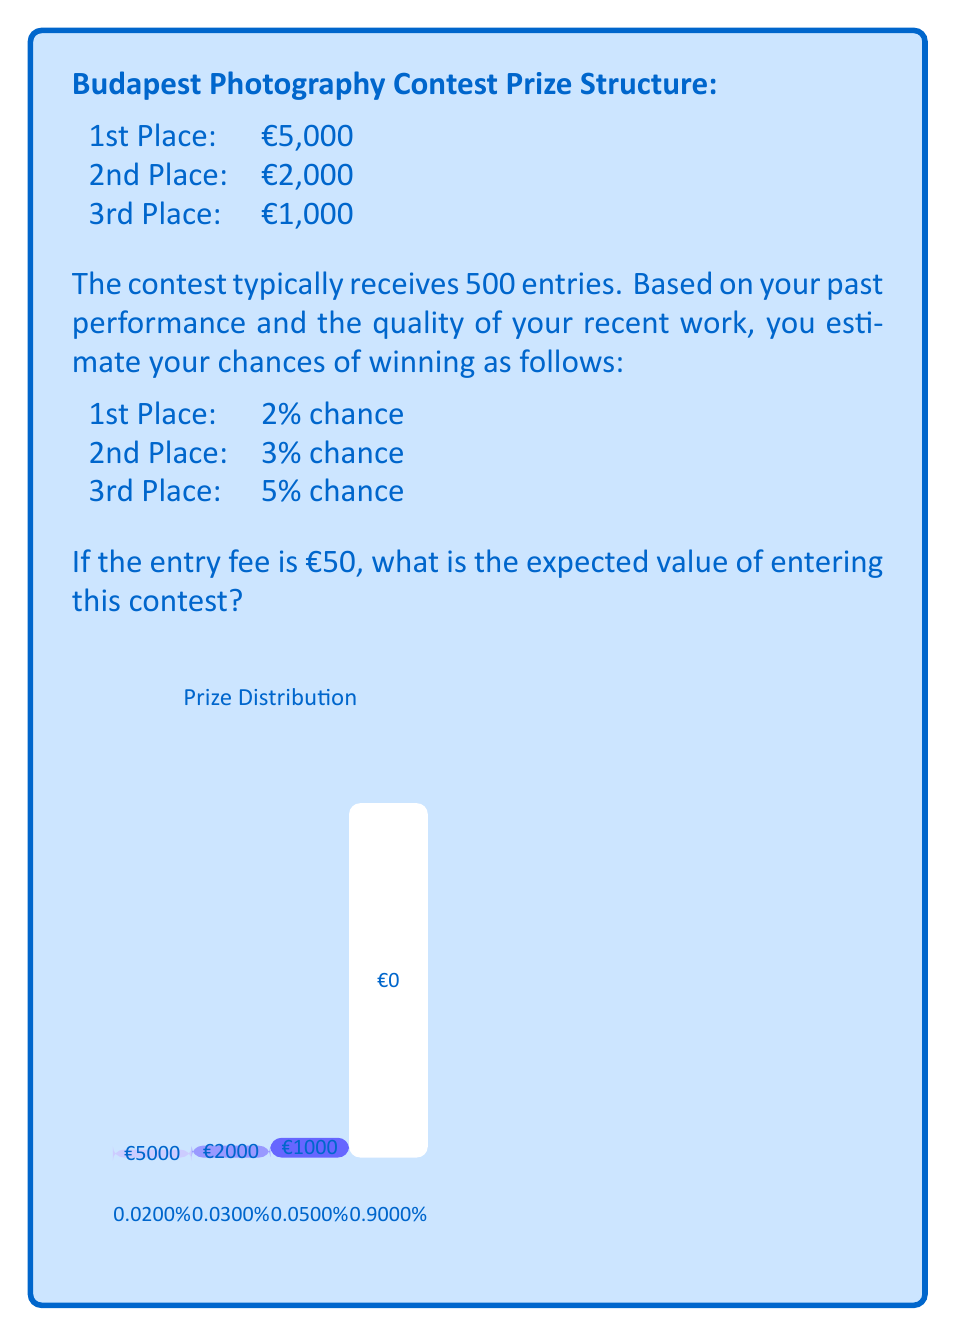Provide a solution to this math problem. To calculate the expected value, we need to:
1. Calculate the potential winnings for each outcome
2. Multiply each outcome by its probability
3. Sum these values
4. Subtract the entry fee

Let's go through this step-by-step:

1. Potential winnings:
   1st Place: €5,000
   2nd Place: €2,000
   3rd Place: €1,000
   No win: €0

2. Multiply each outcome by its probability:
   1st Place: €5,000 * 0.02 = €100
   2nd Place: €2,000 * 0.03 = €60
   3rd Place: €1,000 * 0.05 = €50
   No win: €0 * 0.90 = €0

3. Sum these values:
   $$100 + 60 + 50 + 0 = €210$$

4. Subtract the entry fee:
   $$210 - 50 = €160$$

Therefore, the expected value of entering the contest is €160.

We can express this mathematically as:

$$E = \sum_{i=1}^{n} p_i v_i - c$$

Where:
$E$ is the expected value
$p_i$ is the probability of each outcome
$v_i$ is the value of each outcome
$c$ is the cost of entry

$$E = (0.02 * 5000) + (0.03 * 2000) + (0.05 * 1000) + (0.90 * 0) - 50 = €160$$
Answer: €160 